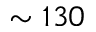Convert formula to latex. <formula><loc_0><loc_0><loc_500><loc_500>\sim 1 3 0</formula> 